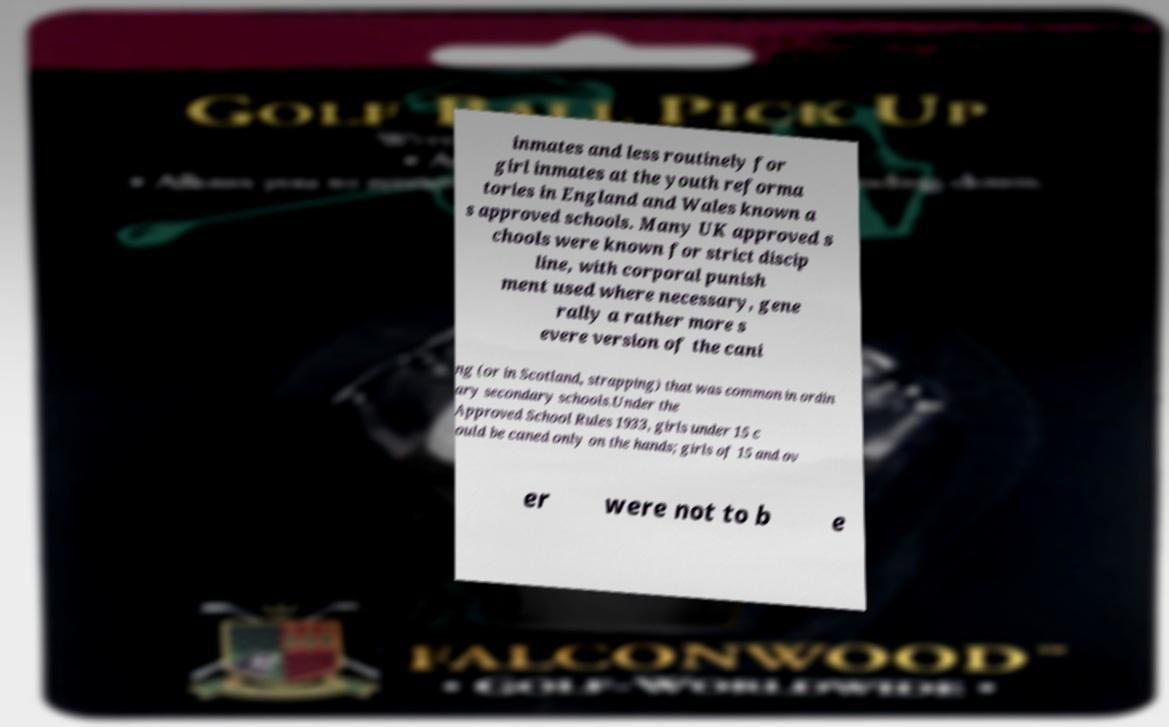There's text embedded in this image that I need extracted. Can you transcribe it verbatim? inmates and less routinely for girl inmates at the youth reforma tories in England and Wales known a s approved schools. Many UK approved s chools were known for strict discip line, with corporal punish ment used where necessary, gene rally a rather more s evere version of the cani ng (or in Scotland, strapping) that was common in ordin ary secondary schools.Under the Approved School Rules 1933, girls under 15 c ould be caned only on the hands; girls of 15 and ov er were not to b e 